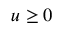Convert formula to latex. <formula><loc_0><loc_0><loc_500><loc_500>u \geq 0</formula> 